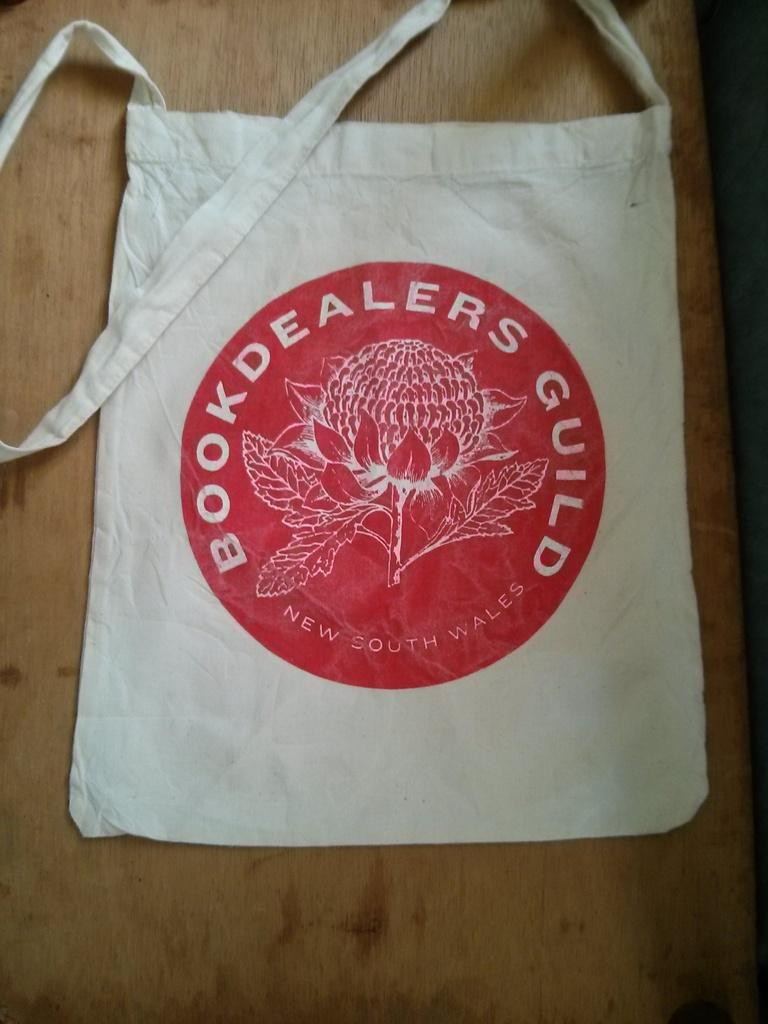What is the color of the bag in the image? The bag in the image is white. What is written on the bag? The words "book dealers guild" are written on the bag. Where is the bag located in the image? The bag is on a wooden table. Can you see a crown on the bag in the image? No, there is no crown present on the bag in the image. Is there a hospital visible in the image? No, there is no hospital present in the image. 